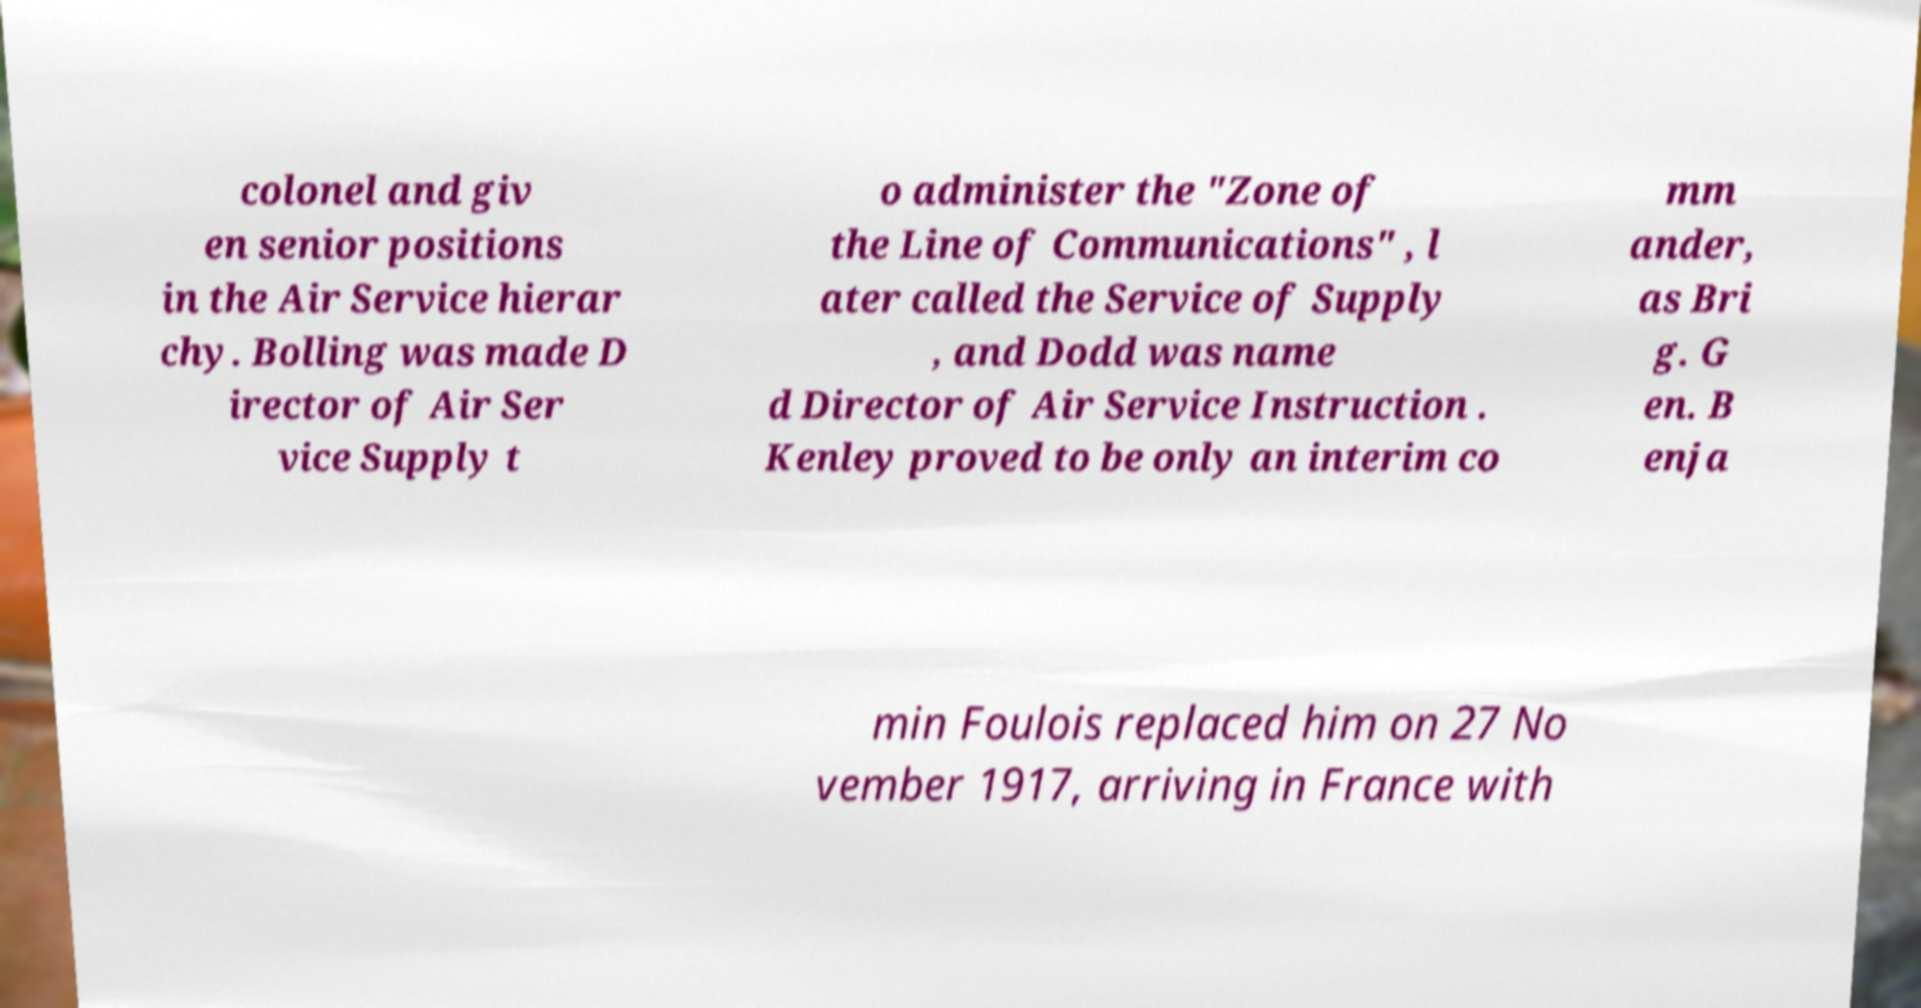Can you accurately transcribe the text from the provided image for me? colonel and giv en senior positions in the Air Service hierar chy. Bolling was made D irector of Air Ser vice Supply t o administer the "Zone of the Line of Communications" , l ater called the Service of Supply , and Dodd was name d Director of Air Service Instruction . Kenley proved to be only an interim co mm ander, as Bri g. G en. B enja min Foulois replaced him on 27 No vember 1917, arriving in France with 